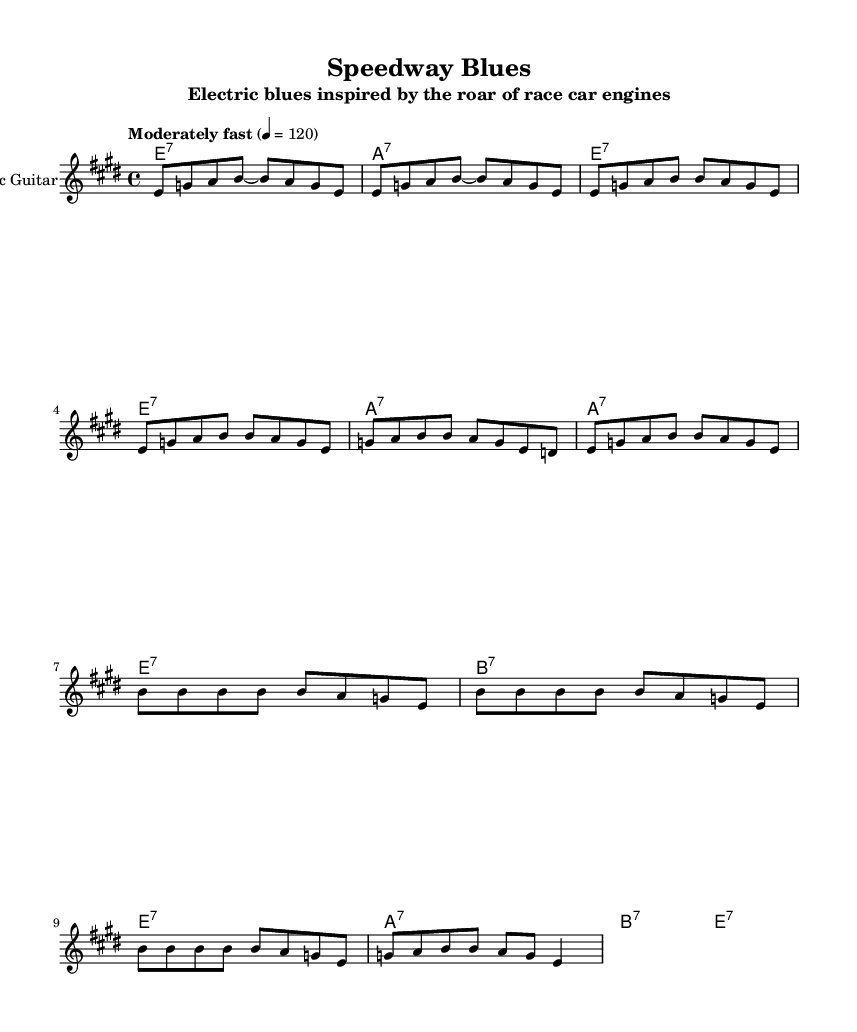What is the key signature of this music? The key signature is E major, which has four sharps (F#, C#, G#, D#).
Answer: E major What is the time signature of this music? The time signature is 4/4, meaning there are four beats per measure.
Answer: 4/4 What is the tempo marking for this piece? The tempo marking indicates "Moderately fast" with a tempo of quarter note equals 120 beats per minute.
Answer: Moderately fast How many measures are in the chorus section? There are four measures in the chorus section, indicated by the repeated musical phrases in that section.
Answer: 4 Which chord appears at the beginning of the verse? The first chord in the verse is E7, as noted in the chord names at the start of the verse section.
Answer: E7 What is the highest note played in the chorus? The highest note in the chorus is B, which is indicated by the notes played in that section.
Answer: B How many different chords are used in the verse? There are three different chords in the verse: E7, A7, and B7, each contributing to the progression.
Answer: 3 